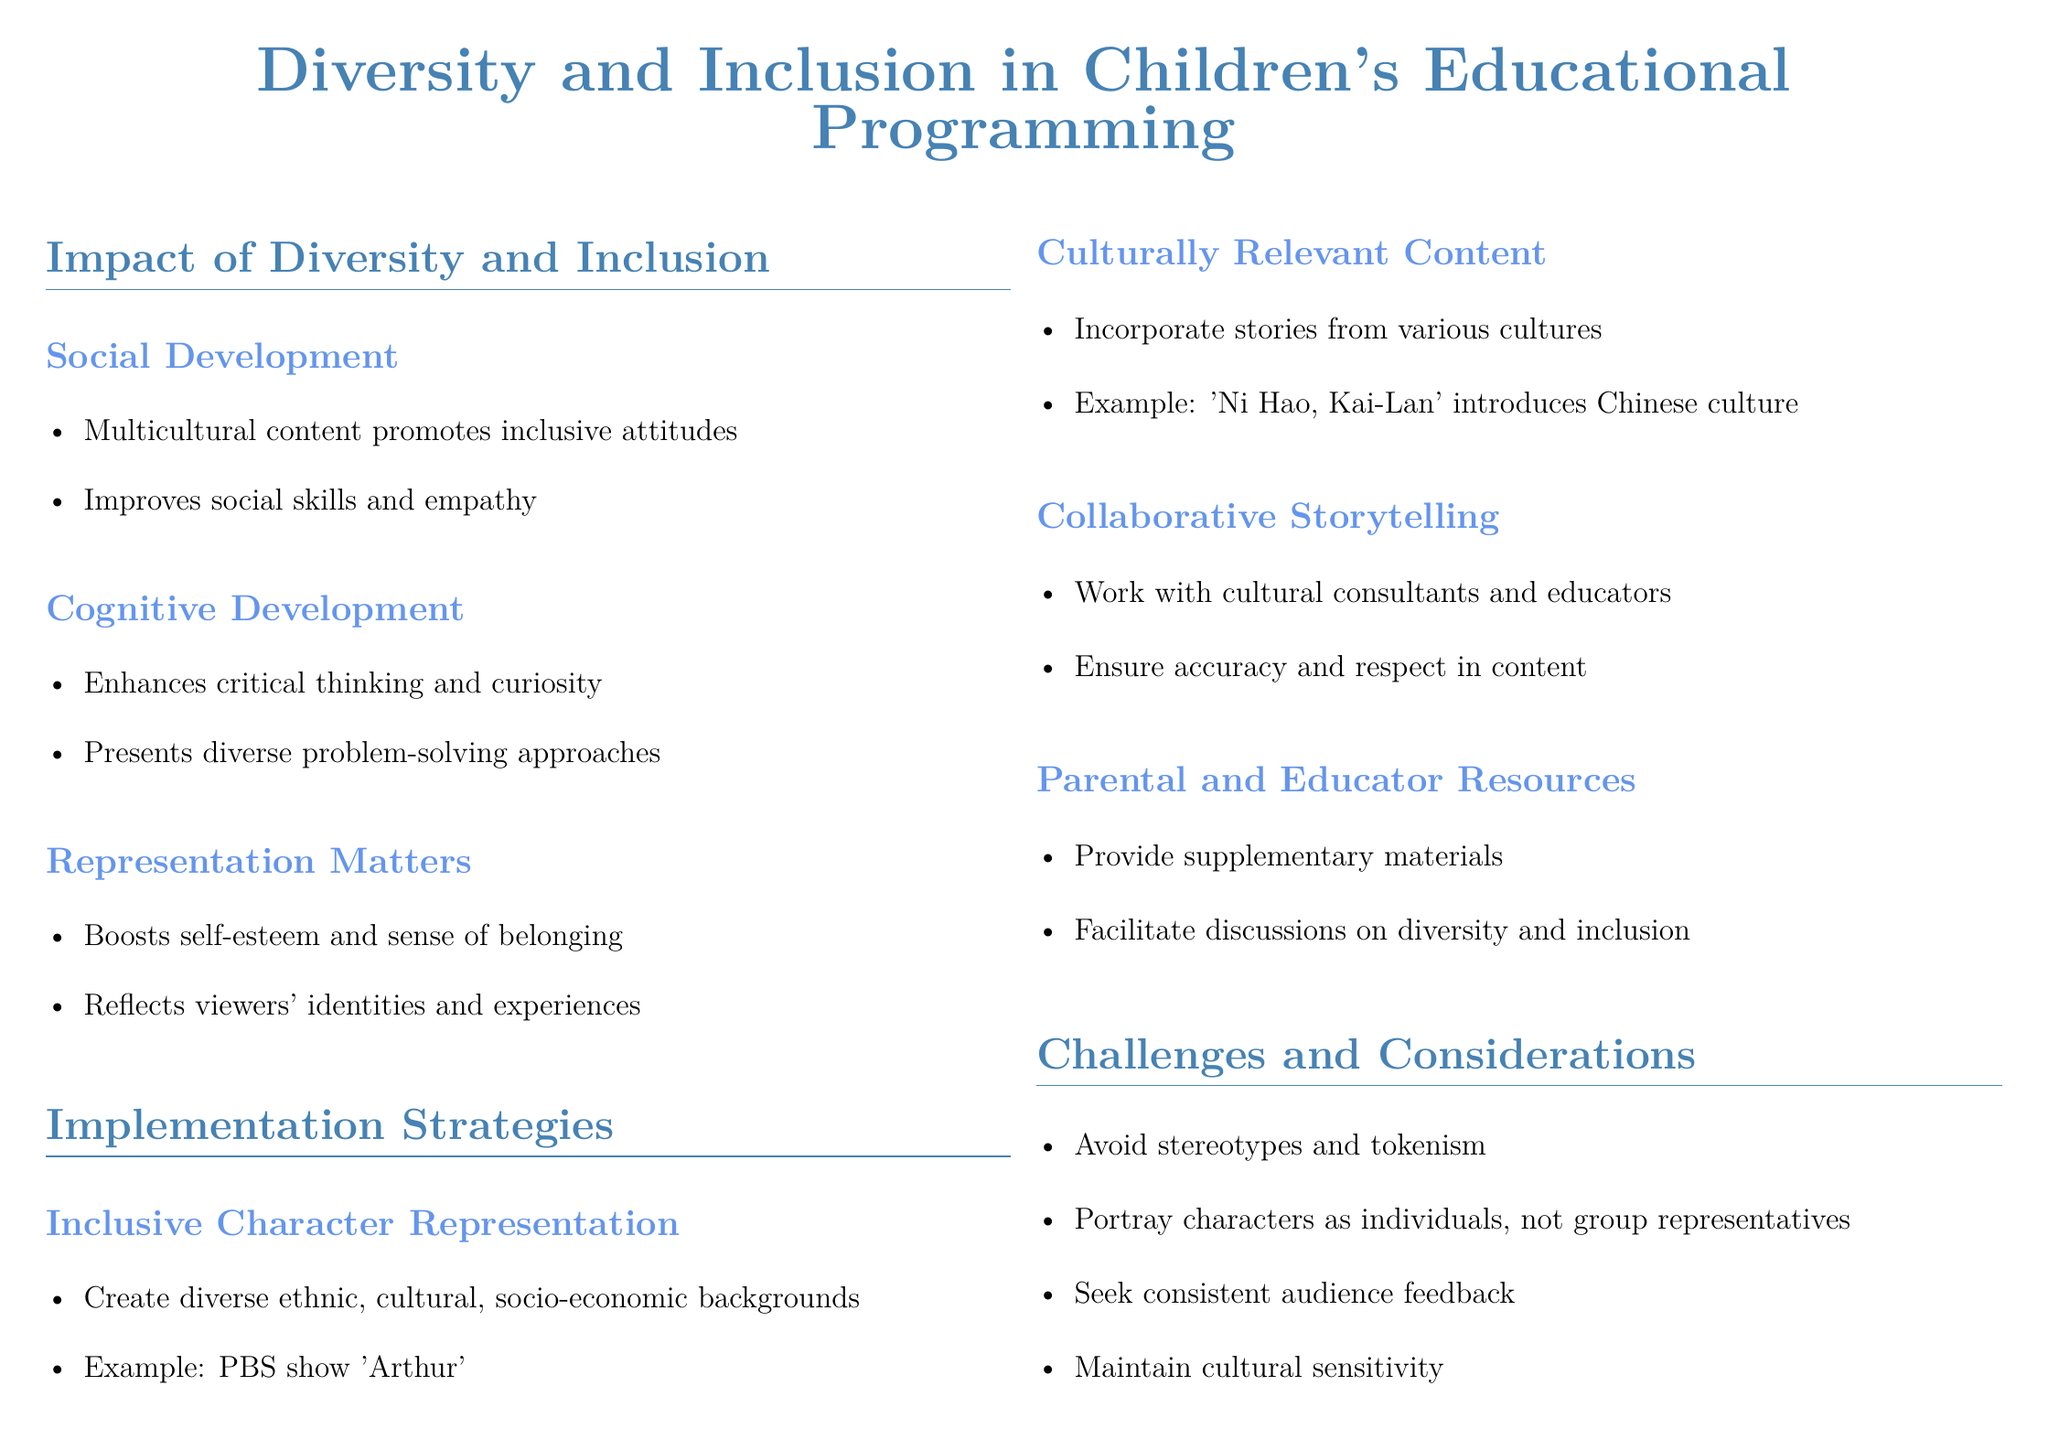What is one impact of diversity on social development? The document mentions that multicultural content enhances inclusive attitudes and improves social skills and empathy.
Answer: Empathy What show is an example of inclusive character representation? The document provides 'Arthur' as an example of creating diverse characters from various backgrounds.
Answer: Arthur What is a cognitive benefit of diversity in programming? The fact sheet states that diversity enhances critical thinking and curiosity.
Answer: Curiosity Which character portrays Black British culture? The document lists 'JoJo & Gran Gran' as a show that highlights Black British culture.
Answer: JoJo & Gran Gran What challenge is mentioned regarding character representation? The fact sheet emphasizes the importance of avoiding stereotypes and portraying characters as individuals, not group representatives.
Answer: Stereotypes What type of content does 'Ni Hao, Kai-Lan' introduce? The document explains that 'Ni Hao, Kai-Lan' incorporates stories from various cultures, specifically introducing Chinese culture.
Answer: Chinese culture Which educational resource does the document recommend for further information? The fact sheet lists the National Association for the Education of Young Children's Guidelines as an additional resource.
Answer: National Association for the Education of Young Children’s Guidelines What does diversity in children's programming contribute to? The conclusion states that diversity enriches the viewing experience and fosters empathy and understanding.
Answer: Empathy and understanding 